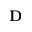<formula> <loc_0><loc_0><loc_500><loc_500>D</formula> 